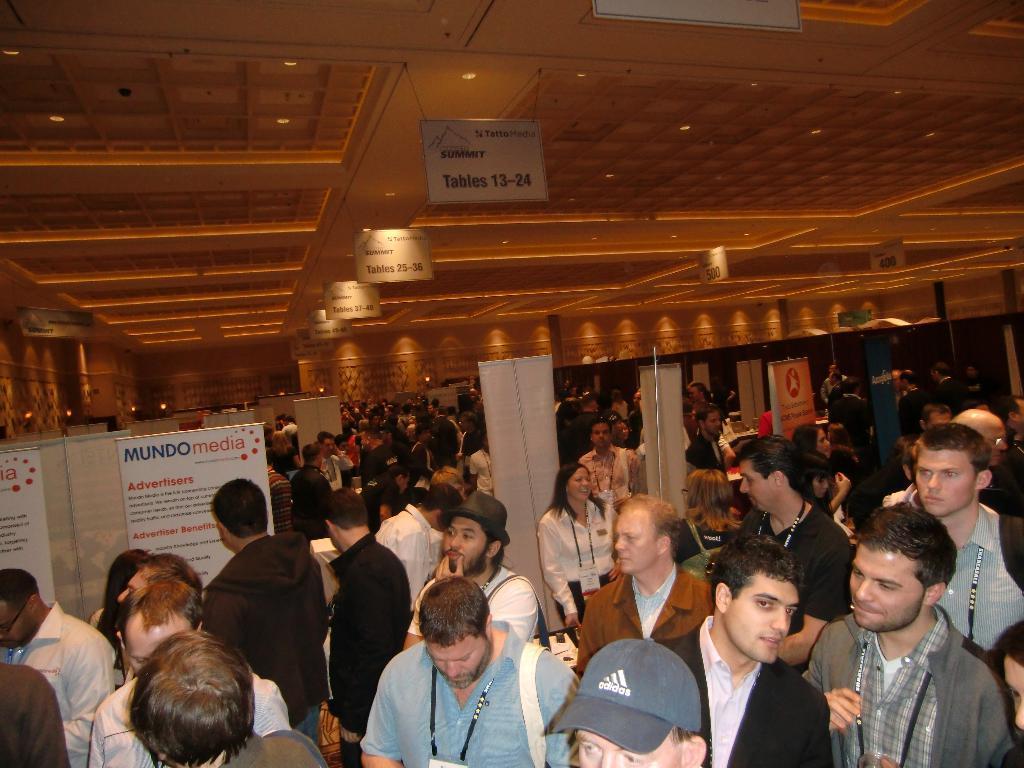Can you describe this image briefly? In this image there are a few people standing, in between them there are few banners. At the top of the image there is a ceiling and few boards are hanging. 